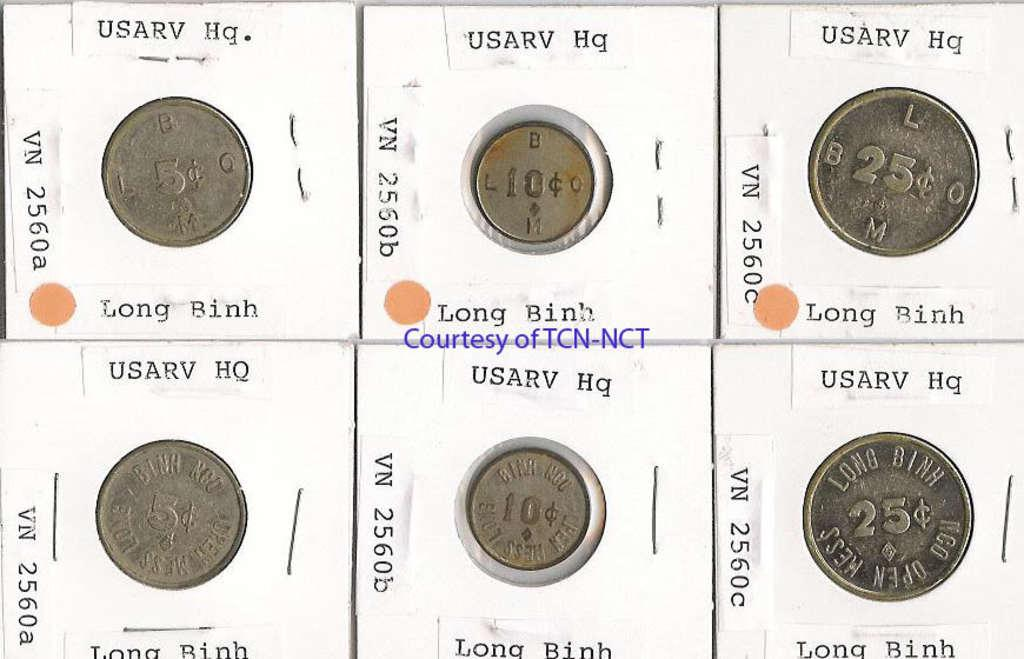<image>
Render a clear and concise summary of the photo. Display of coins with one saying Long Binh and is 25 cents. 